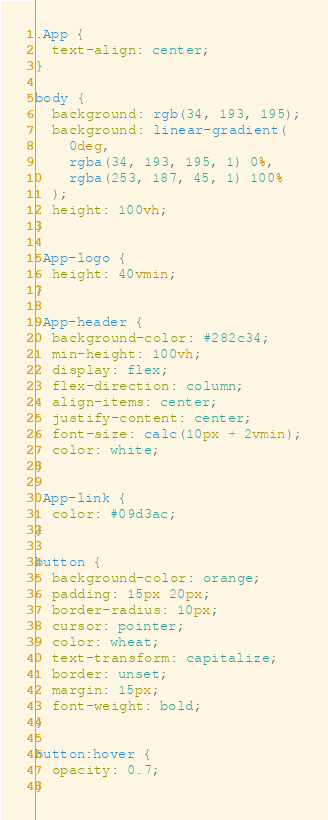Convert code to text. <code><loc_0><loc_0><loc_500><loc_500><_CSS_>.App {
  text-align: center;
}

body {
  background: rgb(34, 193, 195);
  background: linear-gradient(
    0deg,
    rgba(34, 193, 195, 1) 0%,
    rgba(253, 187, 45, 1) 100%
  );
  height: 100vh;
}

.App-logo {
  height: 40vmin;
}

.App-header {
  background-color: #282c34;
  min-height: 100vh;
  display: flex;
  flex-direction: column;
  align-items: center;
  justify-content: center;
  font-size: calc(10px + 2vmin);
  color: white;
}

.App-link {
  color: #09d3ac;
}

button {
  background-color: orange;
  padding: 15px 20px;
  border-radius: 10px;
  cursor: pointer;
  color: wheat;
  text-transform: capitalize;
  border: unset;
  margin: 15px;
  font-weight: bold;
}

button:hover {
  opacity: 0.7;
}
</code> 